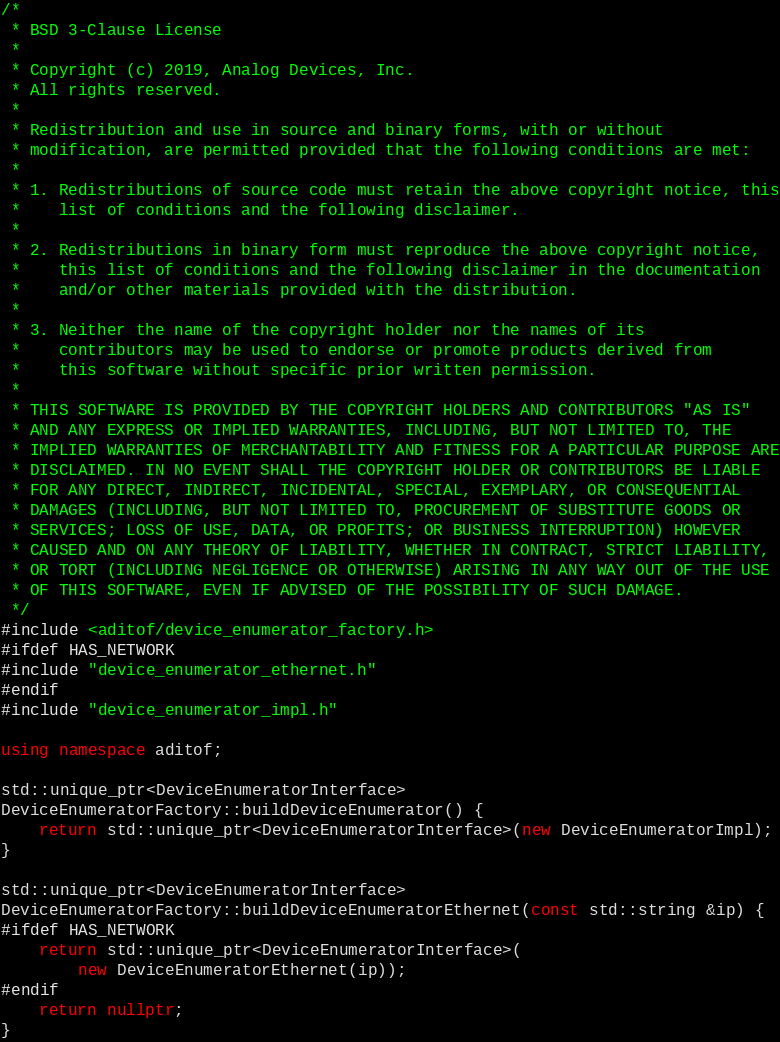<code> <loc_0><loc_0><loc_500><loc_500><_C++_>/*
 * BSD 3-Clause License
 *
 * Copyright (c) 2019, Analog Devices, Inc.
 * All rights reserved.
 *
 * Redistribution and use in source and binary forms, with or without
 * modification, are permitted provided that the following conditions are met:
 *
 * 1. Redistributions of source code must retain the above copyright notice, this
 *    list of conditions and the following disclaimer.
 *
 * 2. Redistributions in binary form must reproduce the above copyright notice,
 *    this list of conditions and the following disclaimer in the documentation
 *    and/or other materials provided with the distribution.
 *
 * 3. Neither the name of the copyright holder nor the names of its
 *    contributors may be used to endorse or promote products derived from
 *    this software without specific prior written permission.
 *
 * THIS SOFTWARE IS PROVIDED BY THE COPYRIGHT HOLDERS AND CONTRIBUTORS "AS IS"
 * AND ANY EXPRESS OR IMPLIED WARRANTIES, INCLUDING, BUT NOT LIMITED TO, THE
 * IMPLIED WARRANTIES OF MERCHANTABILITY AND FITNESS FOR A PARTICULAR PURPOSE ARE
 * DISCLAIMED. IN NO EVENT SHALL THE COPYRIGHT HOLDER OR CONTRIBUTORS BE LIABLE
 * FOR ANY DIRECT, INDIRECT, INCIDENTAL, SPECIAL, EXEMPLARY, OR CONSEQUENTIAL
 * DAMAGES (INCLUDING, BUT NOT LIMITED TO, PROCUREMENT OF SUBSTITUTE GOODS OR
 * SERVICES; LOSS OF USE, DATA, OR PROFITS; OR BUSINESS INTERRUPTION) HOWEVER
 * CAUSED AND ON ANY THEORY OF LIABILITY, WHETHER IN CONTRACT, STRICT LIABILITY,
 * OR TORT (INCLUDING NEGLIGENCE OR OTHERWISE) ARISING IN ANY WAY OUT OF THE USE
 * OF THIS SOFTWARE, EVEN IF ADVISED OF THE POSSIBILITY OF SUCH DAMAGE.
 */
#include <aditof/device_enumerator_factory.h>
#ifdef HAS_NETWORK
#include "device_enumerator_ethernet.h"
#endif
#include "device_enumerator_impl.h"

using namespace aditof;

std::unique_ptr<DeviceEnumeratorInterface>
DeviceEnumeratorFactory::buildDeviceEnumerator() {
    return std::unique_ptr<DeviceEnumeratorInterface>(new DeviceEnumeratorImpl);
}

std::unique_ptr<DeviceEnumeratorInterface>
DeviceEnumeratorFactory::buildDeviceEnumeratorEthernet(const std::string &ip) {
#ifdef HAS_NETWORK
    return std::unique_ptr<DeviceEnumeratorInterface>(
        new DeviceEnumeratorEthernet(ip));
#endif
    return nullptr;
}
</code> 